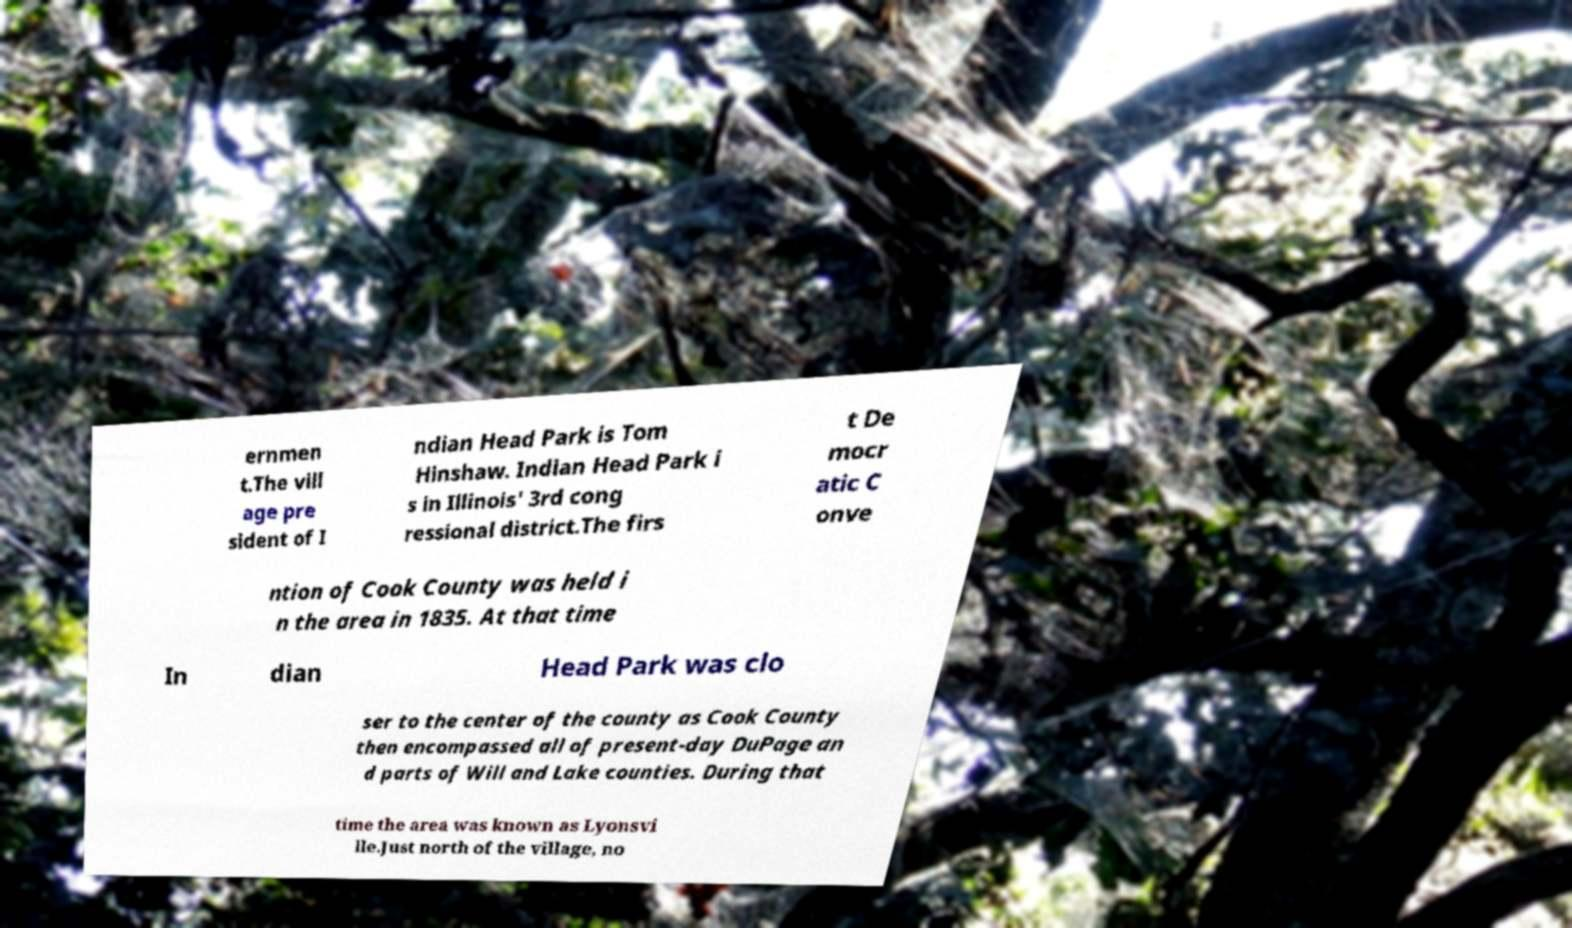There's text embedded in this image that I need extracted. Can you transcribe it verbatim? ernmen t.The vill age pre sident of I ndian Head Park is Tom Hinshaw. Indian Head Park i s in Illinois' 3rd cong ressional district.The firs t De mocr atic C onve ntion of Cook County was held i n the area in 1835. At that time In dian Head Park was clo ser to the center of the county as Cook County then encompassed all of present-day DuPage an d parts of Will and Lake counties. During that time the area was known as Lyonsvi lle.Just north of the village, no 